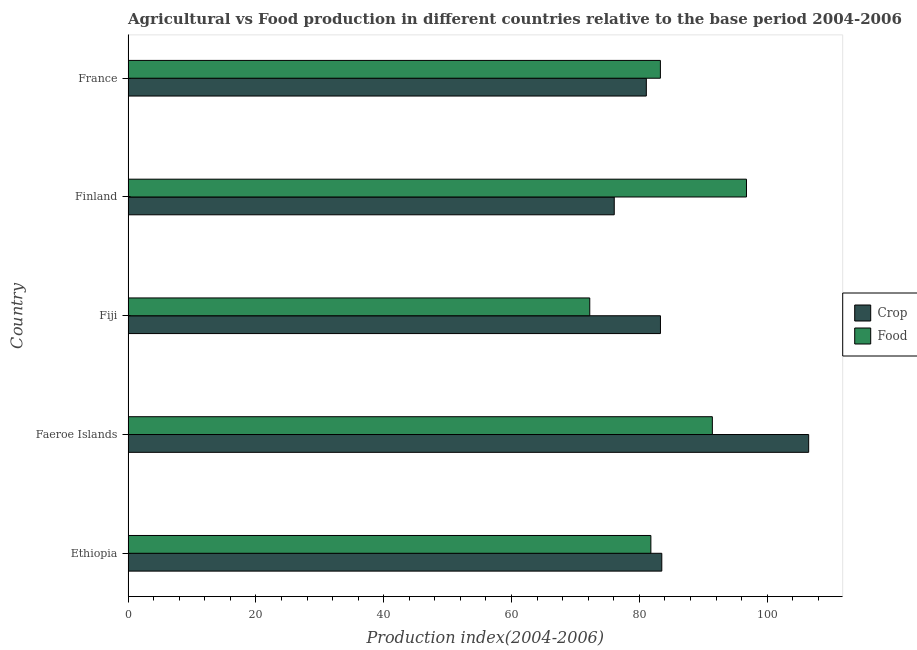Are the number of bars per tick equal to the number of legend labels?
Provide a short and direct response. Yes. Are the number of bars on each tick of the Y-axis equal?
Keep it short and to the point. Yes. How many bars are there on the 1st tick from the top?
Keep it short and to the point. 2. What is the crop production index in Fiji?
Ensure brevity in your answer.  83.3. Across all countries, what is the maximum food production index?
Ensure brevity in your answer.  96.76. Across all countries, what is the minimum crop production index?
Offer a terse response. 76.07. In which country was the crop production index maximum?
Make the answer very short. Faeroe Islands. What is the total crop production index in the graph?
Ensure brevity in your answer.  430.46. What is the difference between the food production index in Ethiopia and that in France?
Your response must be concise. -1.49. What is the difference between the food production index in Ethiopia and the crop production index in Finland?
Give a very brief answer. 5.73. What is the average food production index per country?
Your answer should be very brief. 85.1. What is the difference between the crop production index and food production index in Fiji?
Offer a terse response. 11.06. In how many countries, is the food production index greater than 40 ?
Offer a very short reply. 5. What is the ratio of the food production index in Fiji to that in Finland?
Offer a very short reply. 0.75. Is the difference between the food production index in Finland and France greater than the difference between the crop production index in Finland and France?
Provide a short and direct response. Yes. What is the difference between the highest and the second highest food production index?
Offer a terse response. 5.34. What is the difference between the highest and the lowest crop production index?
Make the answer very short. 30.42. In how many countries, is the food production index greater than the average food production index taken over all countries?
Ensure brevity in your answer.  2. What does the 2nd bar from the top in Fiji represents?
Offer a terse response. Crop. What does the 2nd bar from the bottom in Finland represents?
Your answer should be very brief. Food. How many bars are there?
Make the answer very short. 10. Are all the bars in the graph horizontal?
Give a very brief answer. Yes. How many countries are there in the graph?
Ensure brevity in your answer.  5. What is the difference between two consecutive major ticks on the X-axis?
Offer a terse response. 20. Are the values on the major ticks of X-axis written in scientific E-notation?
Give a very brief answer. No. Does the graph contain any zero values?
Your answer should be very brief. No. Does the graph contain grids?
Provide a succinct answer. No. How are the legend labels stacked?
Make the answer very short. Vertical. What is the title of the graph?
Your answer should be very brief. Agricultural vs Food production in different countries relative to the base period 2004-2006. Does "US$" appear as one of the legend labels in the graph?
Your answer should be very brief. No. What is the label or title of the X-axis?
Provide a short and direct response. Production index(2004-2006). What is the Production index(2004-2006) of Crop in Ethiopia?
Give a very brief answer. 83.51. What is the Production index(2004-2006) in Food in Ethiopia?
Give a very brief answer. 81.8. What is the Production index(2004-2006) in Crop in Faeroe Islands?
Ensure brevity in your answer.  106.49. What is the Production index(2004-2006) in Food in Faeroe Islands?
Your response must be concise. 91.42. What is the Production index(2004-2006) of Crop in Fiji?
Your answer should be very brief. 83.3. What is the Production index(2004-2006) in Food in Fiji?
Keep it short and to the point. 72.24. What is the Production index(2004-2006) of Crop in Finland?
Provide a succinct answer. 76.07. What is the Production index(2004-2006) in Food in Finland?
Keep it short and to the point. 96.76. What is the Production index(2004-2006) of Crop in France?
Ensure brevity in your answer.  81.09. What is the Production index(2004-2006) of Food in France?
Offer a very short reply. 83.29. Across all countries, what is the maximum Production index(2004-2006) in Crop?
Offer a terse response. 106.49. Across all countries, what is the maximum Production index(2004-2006) of Food?
Provide a short and direct response. 96.76. Across all countries, what is the minimum Production index(2004-2006) in Crop?
Your answer should be compact. 76.07. Across all countries, what is the minimum Production index(2004-2006) in Food?
Make the answer very short. 72.24. What is the total Production index(2004-2006) of Crop in the graph?
Make the answer very short. 430.46. What is the total Production index(2004-2006) of Food in the graph?
Ensure brevity in your answer.  425.51. What is the difference between the Production index(2004-2006) of Crop in Ethiopia and that in Faeroe Islands?
Ensure brevity in your answer.  -22.98. What is the difference between the Production index(2004-2006) of Food in Ethiopia and that in Faeroe Islands?
Keep it short and to the point. -9.62. What is the difference between the Production index(2004-2006) in Crop in Ethiopia and that in Fiji?
Your answer should be compact. 0.21. What is the difference between the Production index(2004-2006) of Food in Ethiopia and that in Fiji?
Make the answer very short. 9.56. What is the difference between the Production index(2004-2006) of Crop in Ethiopia and that in Finland?
Offer a very short reply. 7.44. What is the difference between the Production index(2004-2006) of Food in Ethiopia and that in Finland?
Ensure brevity in your answer.  -14.96. What is the difference between the Production index(2004-2006) in Crop in Ethiopia and that in France?
Your answer should be very brief. 2.42. What is the difference between the Production index(2004-2006) of Food in Ethiopia and that in France?
Provide a succinct answer. -1.49. What is the difference between the Production index(2004-2006) of Crop in Faeroe Islands and that in Fiji?
Your answer should be very brief. 23.19. What is the difference between the Production index(2004-2006) of Food in Faeroe Islands and that in Fiji?
Keep it short and to the point. 19.18. What is the difference between the Production index(2004-2006) of Crop in Faeroe Islands and that in Finland?
Keep it short and to the point. 30.42. What is the difference between the Production index(2004-2006) in Food in Faeroe Islands and that in Finland?
Provide a succinct answer. -5.34. What is the difference between the Production index(2004-2006) of Crop in Faeroe Islands and that in France?
Your answer should be compact. 25.4. What is the difference between the Production index(2004-2006) in Food in Faeroe Islands and that in France?
Offer a very short reply. 8.13. What is the difference between the Production index(2004-2006) of Crop in Fiji and that in Finland?
Your answer should be very brief. 7.23. What is the difference between the Production index(2004-2006) of Food in Fiji and that in Finland?
Make the answer very short. -24.52. What is the difference between the Production index(2004-2006) of Crop in Fiji and that in France?
Provide a short and direct response. 2.21. What is the difference between the Production index(2004-2006) of Food in Fiji and that in France?
Ensure brevity in your answer.  -11.05. What is the difference between the Production index(2004-2006) in Crop in Finland and that in France?
Your answer should be compact. -5.02. What is the difference between the Production index(2004-2006) of Food in Finland and that in France?
Offer a very short reply. 13.47. What is the difference between the Production index(2004-2006) in Crop in Ethiopia and the Production index(2004-2006) in Food in Faeroe Islands?
Make the answer very short. -7.91. What is the difference between the Production index(2004-2006) in Crop in Ethiopia and the Production index(2004-2006) in Food in Fiji?
Provide a short and direct response. 11.27. What is the difference between the Production index(2004-2006) in Crop in Ethiopia and the Production index(2004-2006) in Food in Finland?
Make the answer very short. -13.25. What is the difference between the Production index(2004-2006) in Crop in Ethiopia and the Production index(2004-2006) in Food in France?
Give a very brief answer. 0.22. What is the difference between the Production index(2004-2006) in Crop in Faeroe Islands and the Production index(2004-2006) in Food in Fiji?
Make the answer very short. 34.25. What is the difference between the Production index(2004-2006) in Crop in Faeroe Islands and the Production index(2004-2006) in Food in Finland?
Offer a terse response. 9.73. What is the difference between the Production index(2004-2006) in Crop in Faeroe Islands and the Production index(2004-2006) in Food in France?
Provide a succinct answer. 23.2. What is the difference between the Production index(2004-2006) in Crop in Fiji and the Production index(2004-2006) in Food in Finland?
Provide a succinct answer. -13.46. What is the difference between the Production index(2004-2006) of Crop in Finland and the Production index(2004-2006) of Food in France?
Your answer should be very brief. -7.22. What is the average Production index(2004-2006) in Crop per country?
Your answer should be compact. 86.09. What is the average Production index(2004-2006) of Food per country?
Offer a very short reply. 85.1. What is the difference between the Production index(2004-2006) of Crop and Production index(2004-2006) of Food in Ethiopia?
Ensure brevity in your answer.  1.71. What is the difference between the Production index(2004-2006) in Crop and Production index(2004-2006) in Food in Faeroe Islands?
Make the answer very short. 15.07. What is the difference between the Production index(2004-2006) of Crop and Production index(2004-2006) of Food in Fiji?
Make the answer very short. 11.06. What is the difference between the Production index(2004-2006) in Crop and Production index(2004-2006) in Food in Finland?
Offer a very short reply. -20.69. What is the difference between the Production index(2004-2006) in Crop and Production index(2004-2006) in Food in France?
Your response must be concise. -2.2. What is the ratio of the Production index(2004-2006) of Crop in Ethiopia to that in Faeroe Islands?
Provide a short and direct response. 0.78. What is the ratio of the Production index(2004-2006) in Food in Ethiopia to that in Faeroe Islands?
Offer a terse response. 0.89. What is the ratio of the Production index(2004-2006) in Crop in Ethiopia to that in Fiji?
Keep it short and to the point. 1. What is the ratio of the Production index(2004-2006) of Food in Ethiopia to that in Fiji?
Your answer should be compact. 1.13. What is the ratio of the Production index(2004-2006) of Crop in Ethiopia to that in Finland?
Provide a short and direct response. 1.1. What is the ratio of the Production index(2004-2006) of Food in Ethiopia to that in Finland?
Offer a very short reply. 0.85. What is the ratio of the Production index(2004-2006) in Crop in Ethiopia to that in France?
Offer a terse response. 1.03. What is the ratio of the Production index(2004-2006) of Food in Ethiopia to that in France?
Your answer should be compact. 0.98. What is the ratio of the Production index(2004-2006) in Crop in Faeroe Islands to that in Fiji?
Provide a short and direct response. 1.28. What is the ratio of the Production index(2004-2006) in Food in Faeroe Islands to that in Fiji?
Your answer should be compact. 1.27. What is the ratio of the Production index(2004-2006) of Crop in Faeroe Islands to that in Finland?
Offer a terse response. 1.4. What is the ratio of the Production index(2004-2006) of Food in Faeroe Islands to that in Finland?
Keep it short and to the point. 0.94. What is the ratio of the Production index(2004-2006) of Crop in Faeroe Islands to that in France?
Keep it short and to the point. 1.31. What is the ratio of the Production index(2004-2006) in Food in Faeroe Islands to that in France?
Keep it short and to the point. 1.1. What is the ratio of the Production index(2004-2006) of Crop in Fiji to that in Finland?
Your answer should be very brief. 1.09. What is the ratio of the Production index(2004-2006) of Food in Fiji to that in Finland?
Keep it short and to the point. 0.75. What is the ratio of the Production index(2004-2006) in Crop in Fiji to that in France?
Provide a succinct answer. 1.03. What is the ratio of the Production index(2004-2006) of Food in Fiji to that in France?
Keep it short and to the point. 0.87. What is the ratio of the Production index(2004-2006) of Crop in Finland to that in France?
Make the answer very short. 0.94. What is the ratio of the Production index(2004-2006) of Food in Finland to that in France?
Keep it short and to the point. 1.16. What is the difference between the highest and the second highest Production index(2004-2006) of Crop?
Keep it short and to the point. 22.98. What is the difference between the highest and the second highest Production index(2004-2006) of Food?
Offer a terse response. 5.34. What is the difference between the highest and the lowest Production index(2004-2006) in Crop?
Your answer should be very brief. 30.42. What is the difference between the highest and the lowest Production index(2004-2006) of Food?
Give a very brief answer. 24.52. 